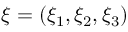<formula> <loc_0><loc_0><loc_500><loc_500>\xi = ( \xi _ { 1 } , \xi _ { 2 } , \xi _ { 3 } )</formula> 